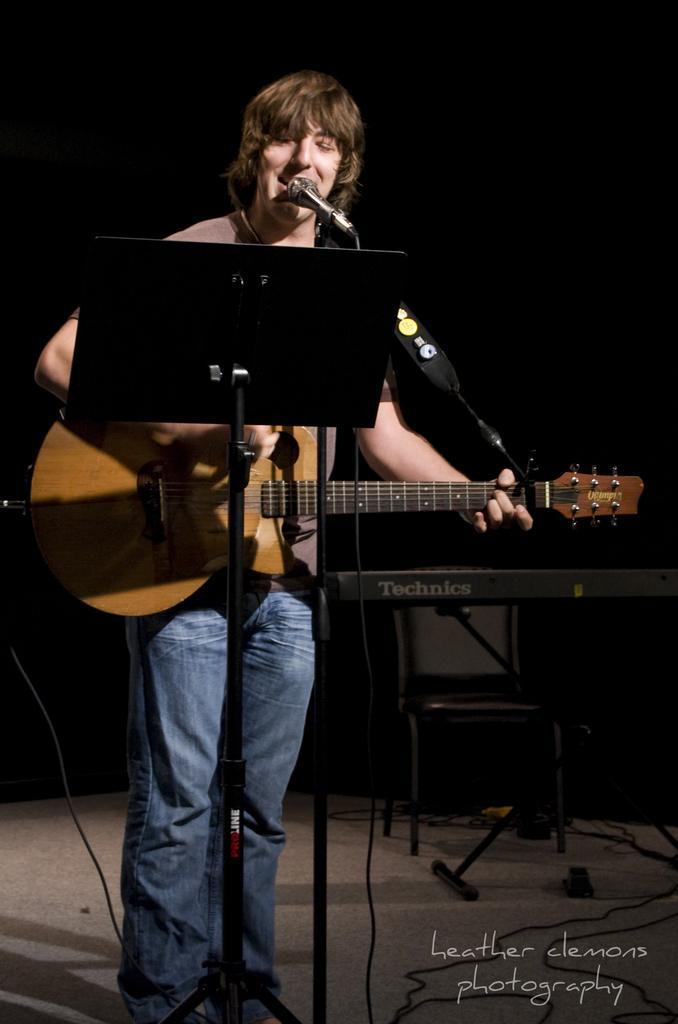Can you describe this image briefly? In this image I can see a person standing. In-front of him there is a mic and he is playing guitar and singing. 